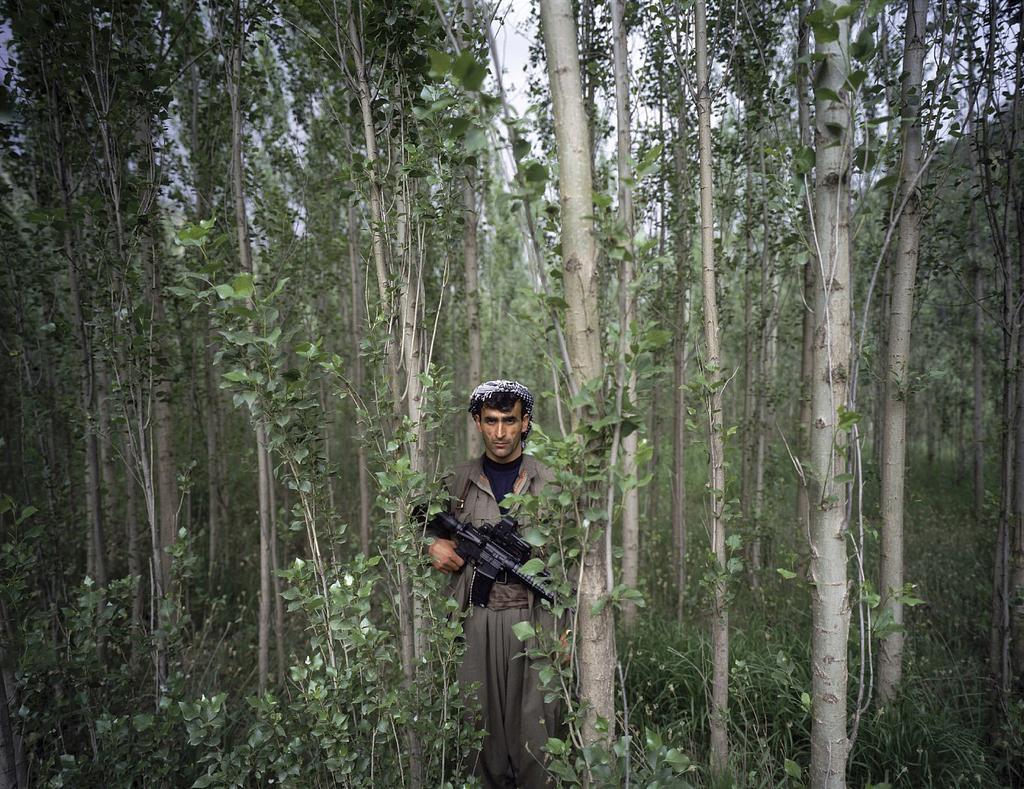Can you describe this image briefly? In the center of the picture there is a person standing, holding a gun. In this picture there are trees and plants. 